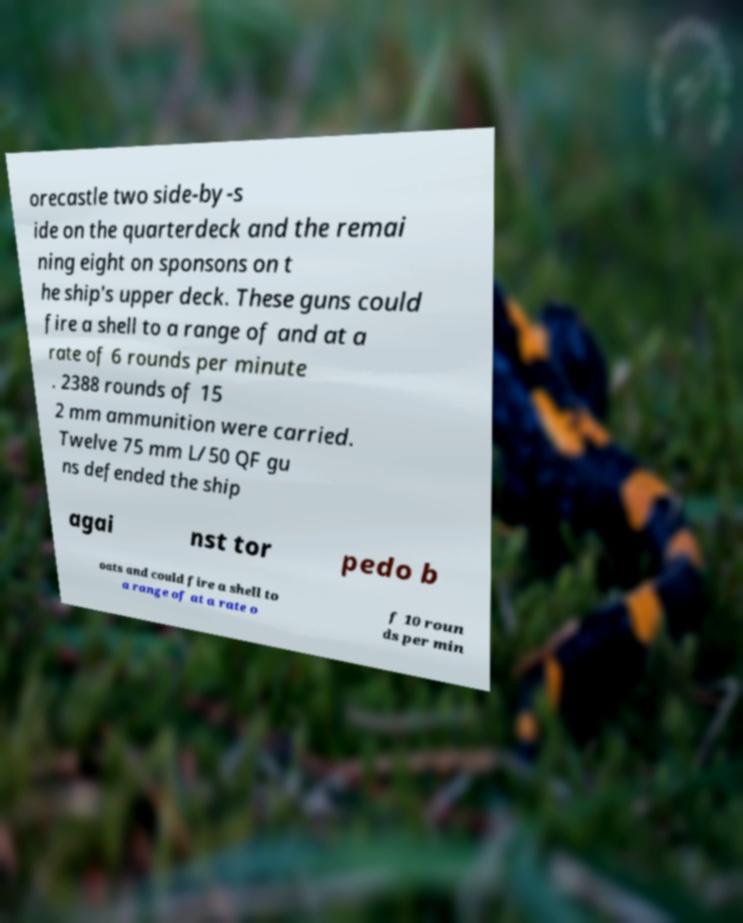What messages or text are displayed in this image? I need them in a readable, typed format. orecastle two side-by-s ide on the quarterdeck and the remai ning eight on sponsons on t he ship's upper deck. These guns could fire a shell to a range of and at a rate of 6 rounds per minute . 2388 rounds of 15 2 mm ammunition were carried. Twelve 75 mm L/50 QF gu ns defended the ship agai nst tor pedo b oats and could fire a shell to a range of at a rate o f 10 roun ds per min 